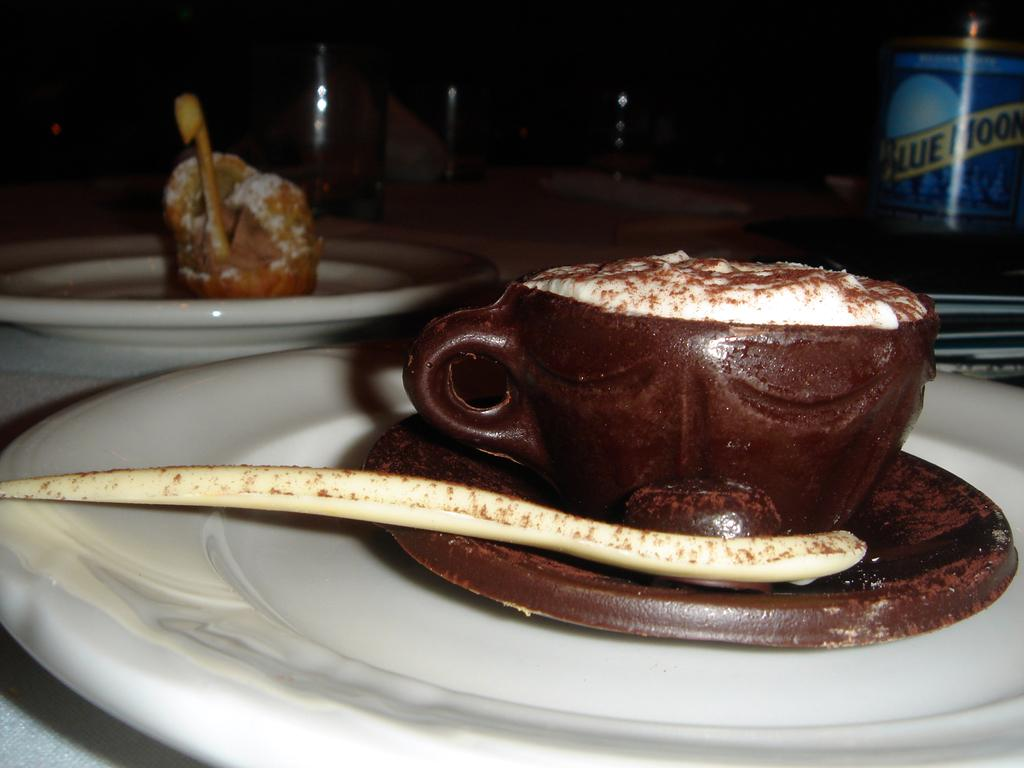What piece of furniture is present in the image? There is a table in the image. What objects are placed on the table? There are two white plates and cakes in the shape of cups on the table. What is the color of the cakes? The cakes are brown in color. Where is the rabbit sitting on the table in the image? There is no rabbit present in the image. What type of iron is used to make the cakes in the image? The cakes are not made of iron; they are made of a baked good, likely cake or pastry. 